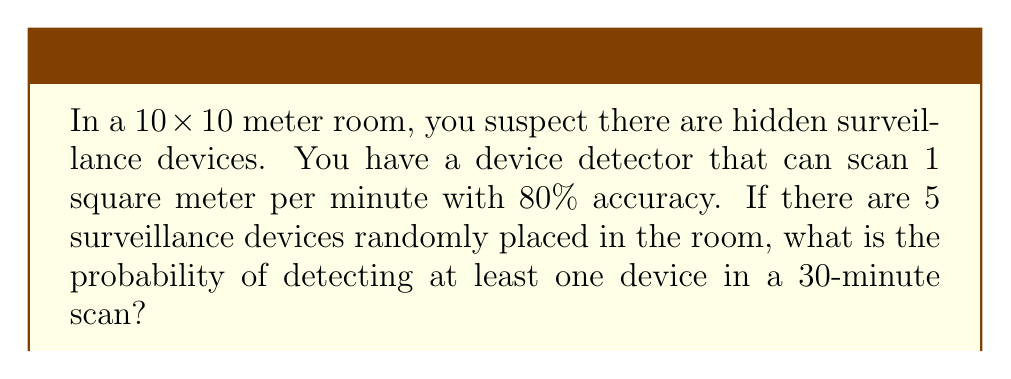Solve this math problem. Let's approach this step-by-step:

1) First, calculate the area scanned in 30 minutes:
   $$30 \text{ minutes} \times 1 \text{ m}^2/\text{minute} = 30 \text{ m}^2$$

2) The probability of a single device being in the scanned area:
   $$P(\text{device in scanned area}) = \frac{30 \text{ m}^2}{100 \text{ m}^2} = 0.3$$

3) The probability of not detecting a device that is in the scanned area (due to 80% accuracy):
   $$P(\text{not detecting | in area}) = 1 - 0.8 = 0.2$$

4) The probability of not detecting a specific device:
   $$P(\text{not detecting}) = 1 - (0.3 \times 0.8) = 0.76$$

5) The probability of not detecting any of the 5 devices:
   $$P(\text{not detecting any}) = 0.76^5 \approx 0.2373$$

6) Therefore, the probability of detecting at least one device:
   $$P(\text{detecting at least one}) = 1 - P(\text{not detecting any}) = 1 - 0.2373 \approx 0.7627$$
Answer: $0.7627$ or $76.27\%$ 